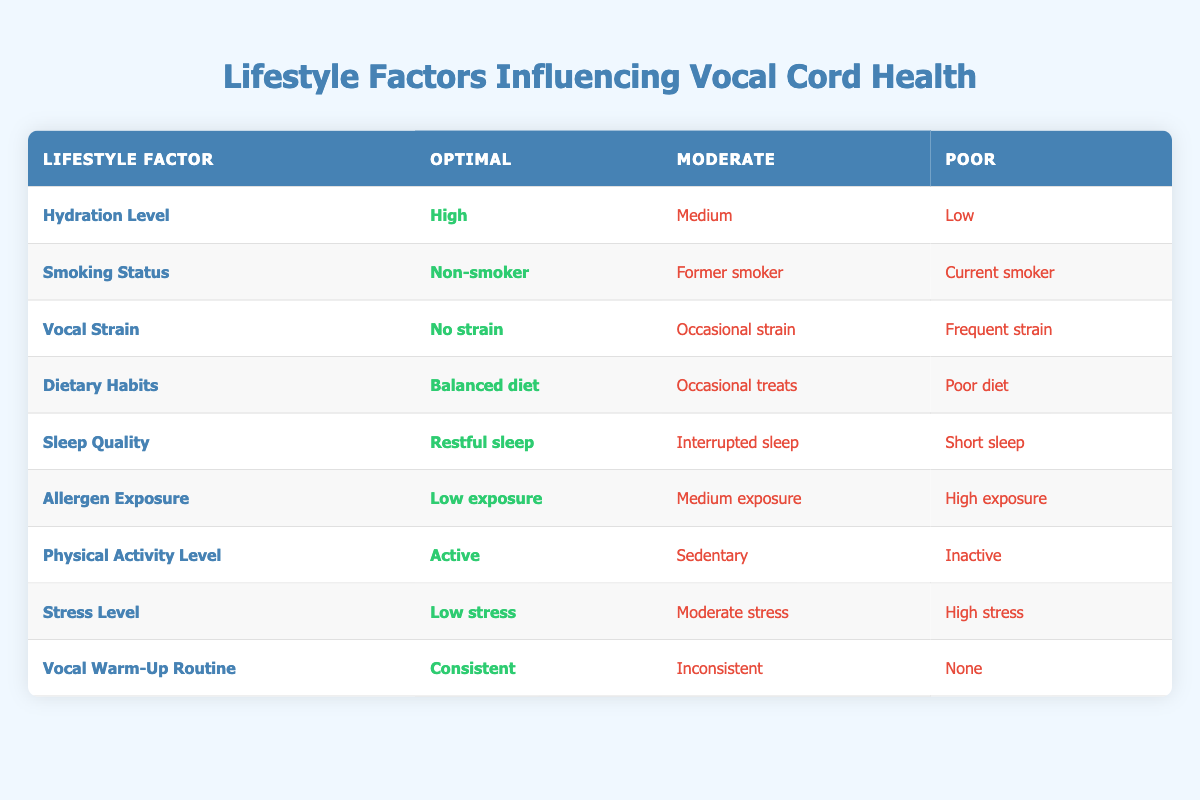What lifestyle factor shows high hydration level? According to the table, the lifestyle factor "Hydration Level" has "High" under the Optimal column, indicating that this is the recommended level for hydration.
Answer: Hydration Level Is there a lifestyle factor with a moderate level of vocal strain? The table indicates that for "Vocal Strain," there are no entries under the Moderate column; it only shows "No strain" as Optimal. Thus, there are no moderate levels.
Answer: No What is the total number of factors assessed in the table? By counting the rows in the table, there are 9 lifestyle factors listed, which can be tallied from the visible entries.
Answer: 9 Which factors recommend a balanced approach for vocal cord health? The factors that recommend optimal conditions for vocal cord health are: Hydration Level (High), Smoking Status (Non-smoker), Vocal Strain (No strain), Dietary Habits (Balanced diet), Sleep Quality (Restful sleep), Allergen Exposure (Low exposure), Physical Activity Level (Active), Stress Level (Low stress), and Vocal Warm-Up Routine (Consistent). This means all factors recommend a balanced approach.
Answer: All factors If a client has high allergen exposure and insufficient sleep quality, how would that impact their vocal cord health? High Allergen Exposure is categorized poorly, and Short Sleep is also deemed poor. Since both of these factors are under the Poor category, the overall impact would likely be negative for vocal cord health, as both conditions are detrimental.
Answer: Negative impact 